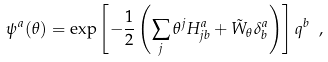<formula> <loc_0><loc_0><loc_500><loc_500>\psi ^ { a } ( \theta ) = \exp \left [ - \frac { 1 } { 2 } \left ( \sum _ { j } \theta ^ { j } H ^ { a } _ { j b } + { \tilde { W } } _ { \theta } \delta ^ { a } _ { b } \right ) \right ] q ^ { b } \ ,</formula> 